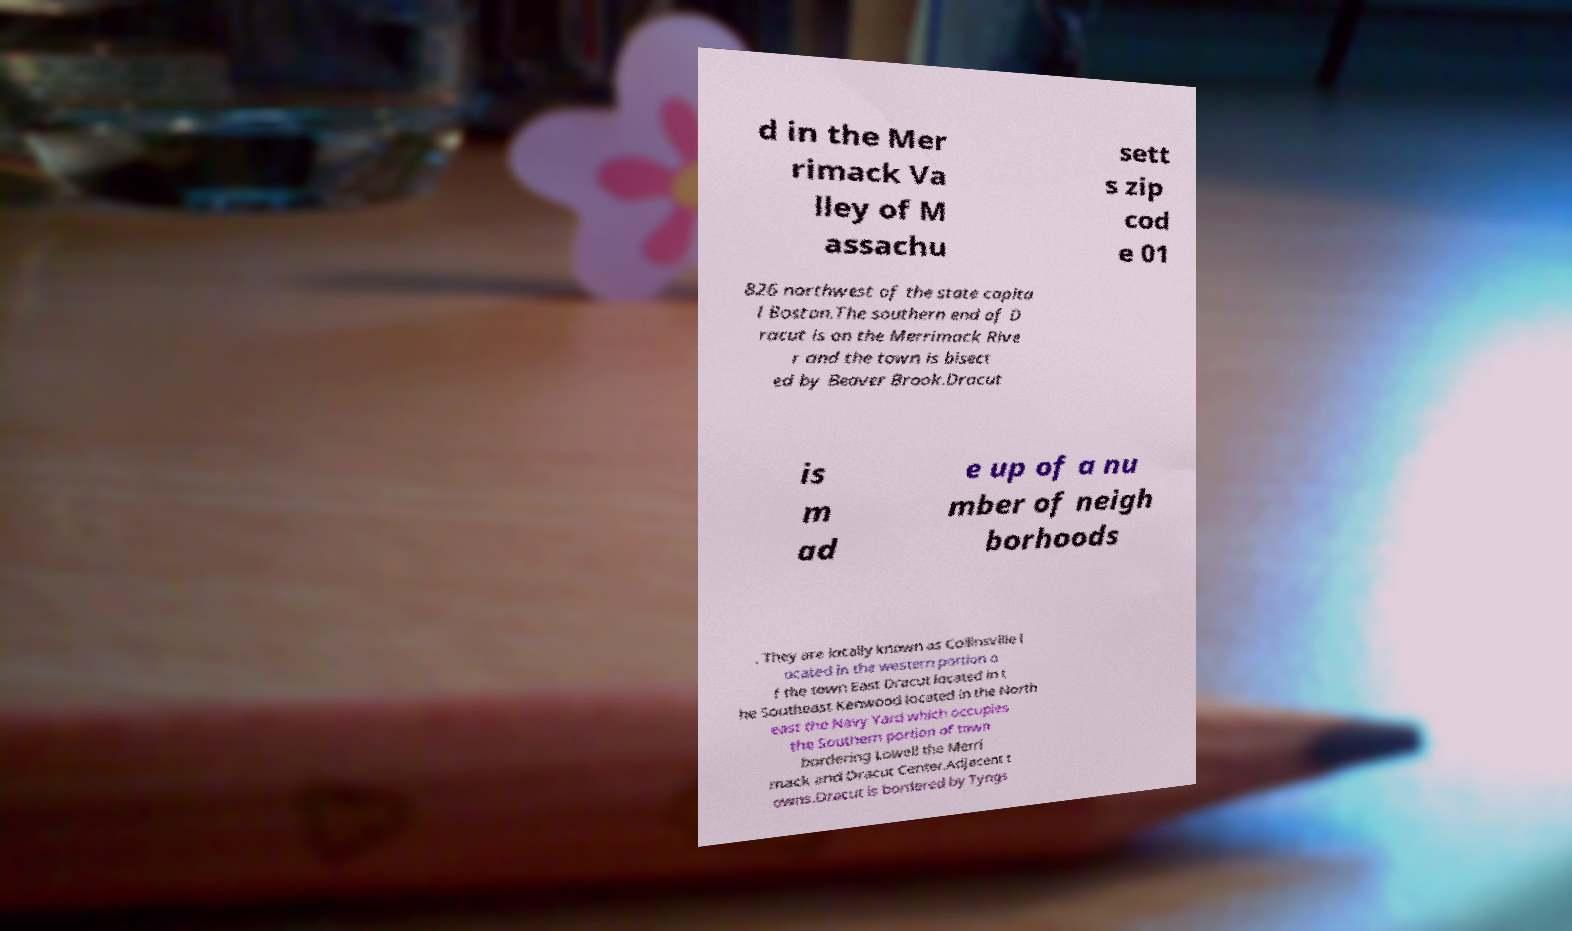Please identify and transcribe the text found in this image. d in the Mer rimack Va lley of M assachu sett s zip cod e 01 826 northwest of the state capita l Boston.The southern end of D racut is on the Merrimack Rive r and the town is bisect ed by Beaver Brook.Dracut is m ad e up of a nu mber of neigh borhoods . They are locally known as Collinsville l ocated in the western portion o f the town East Dracut located in t he Southeast Kenwood located in the North east the Navy Yard which occupies the Southern portion of town bordering Lowell the Merri mack and Dracut Center.Adjacent t owns.Dracut is bordered by Tyngs 